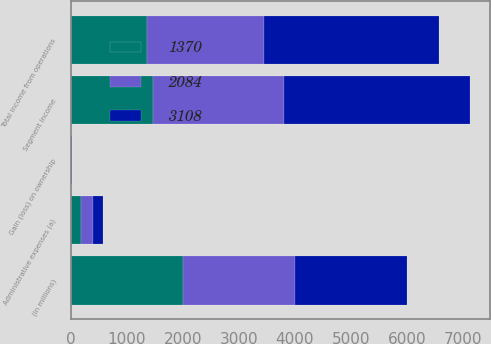Convert chart. <chart><loc_0><loc_0><loc_500><loc_500><stacked_bar_chart><ecel><fcel>(In millions)<fcel>Segment income<fcel>Administrative expenses (a)<fcel>Gain (loss) on ownership<fcel>Total income from operations<nl><fcel>2084<fcel>2003<fcel>2330<fcel>203<fcel>1<fcel>2084<nl><fcel>1370<fcel>2002<fcel>1472<fcel>194<fcel>12<fcel>1370<nl><fcel>3108<fcel>2001<fcel>3327<fcel>187<fcel>6<fcel>3108<nl></chart> 